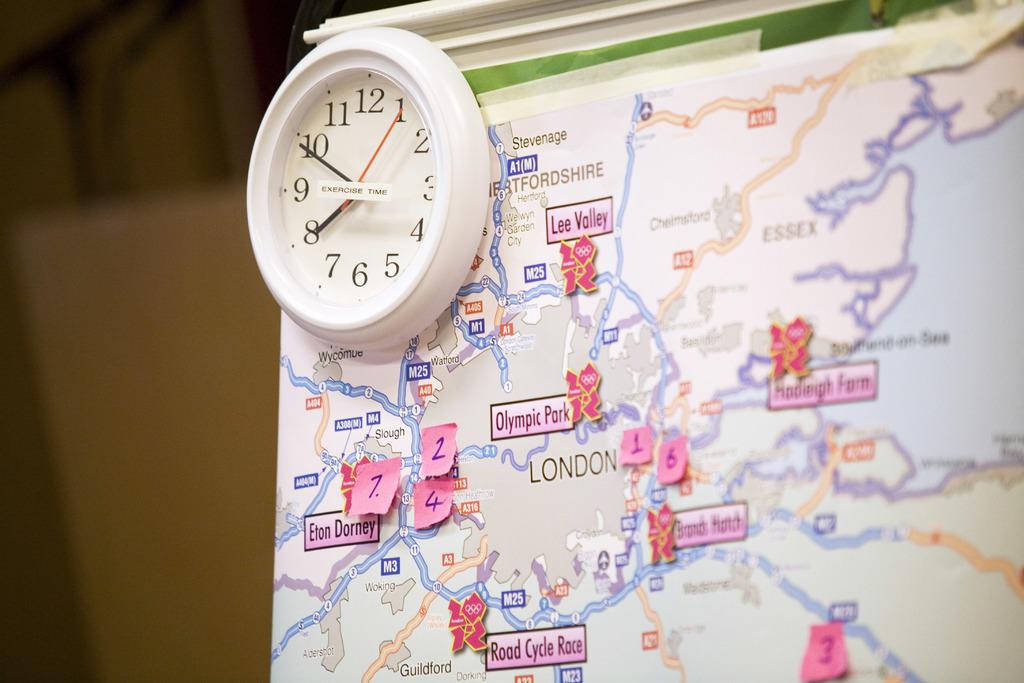What is the map of?
Give a very brief answer. London. Which park is on the map?
Make the answer very short. Olympic. 